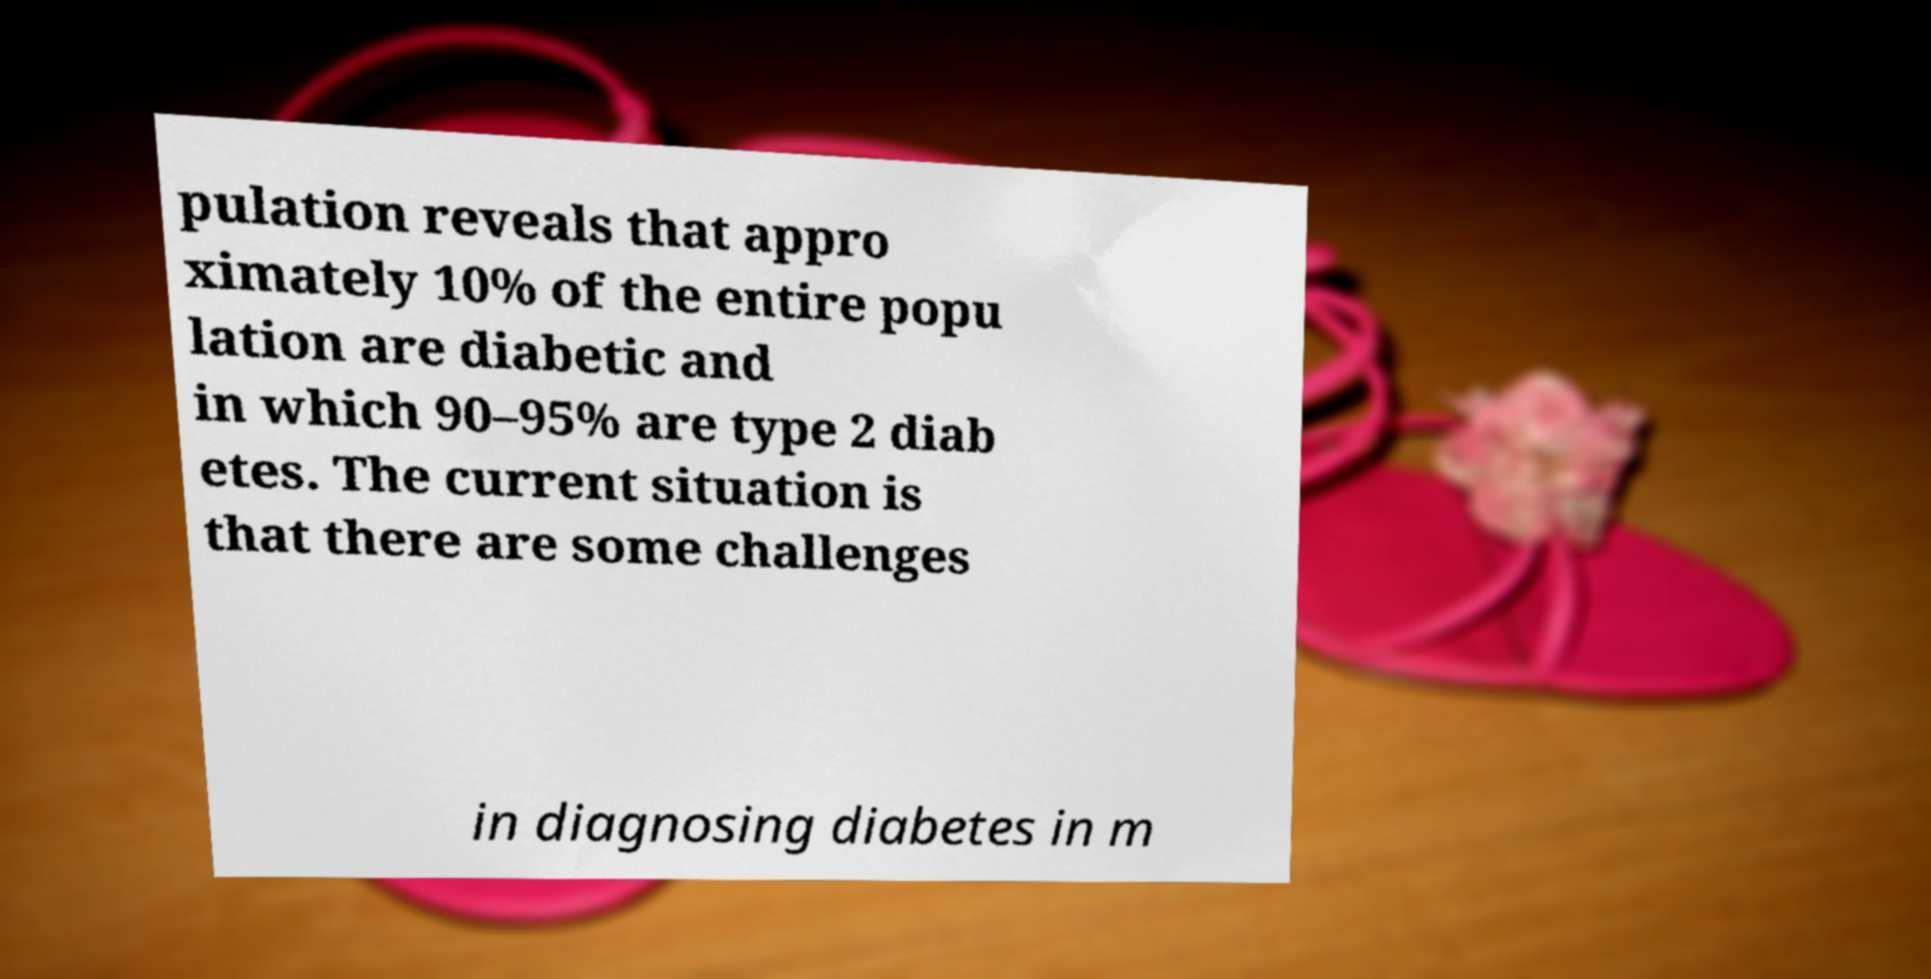Can you read and provide the text displayed in the image?This photo seems to have some interesting text. Can you extract and type it out for me? pulation reveals that appro ximately 10% of the entire popu lation are diabetic and in which 90–95% are type 2 diab etes. The current situation is that there are some challenges in diagnosing diabetes in m 